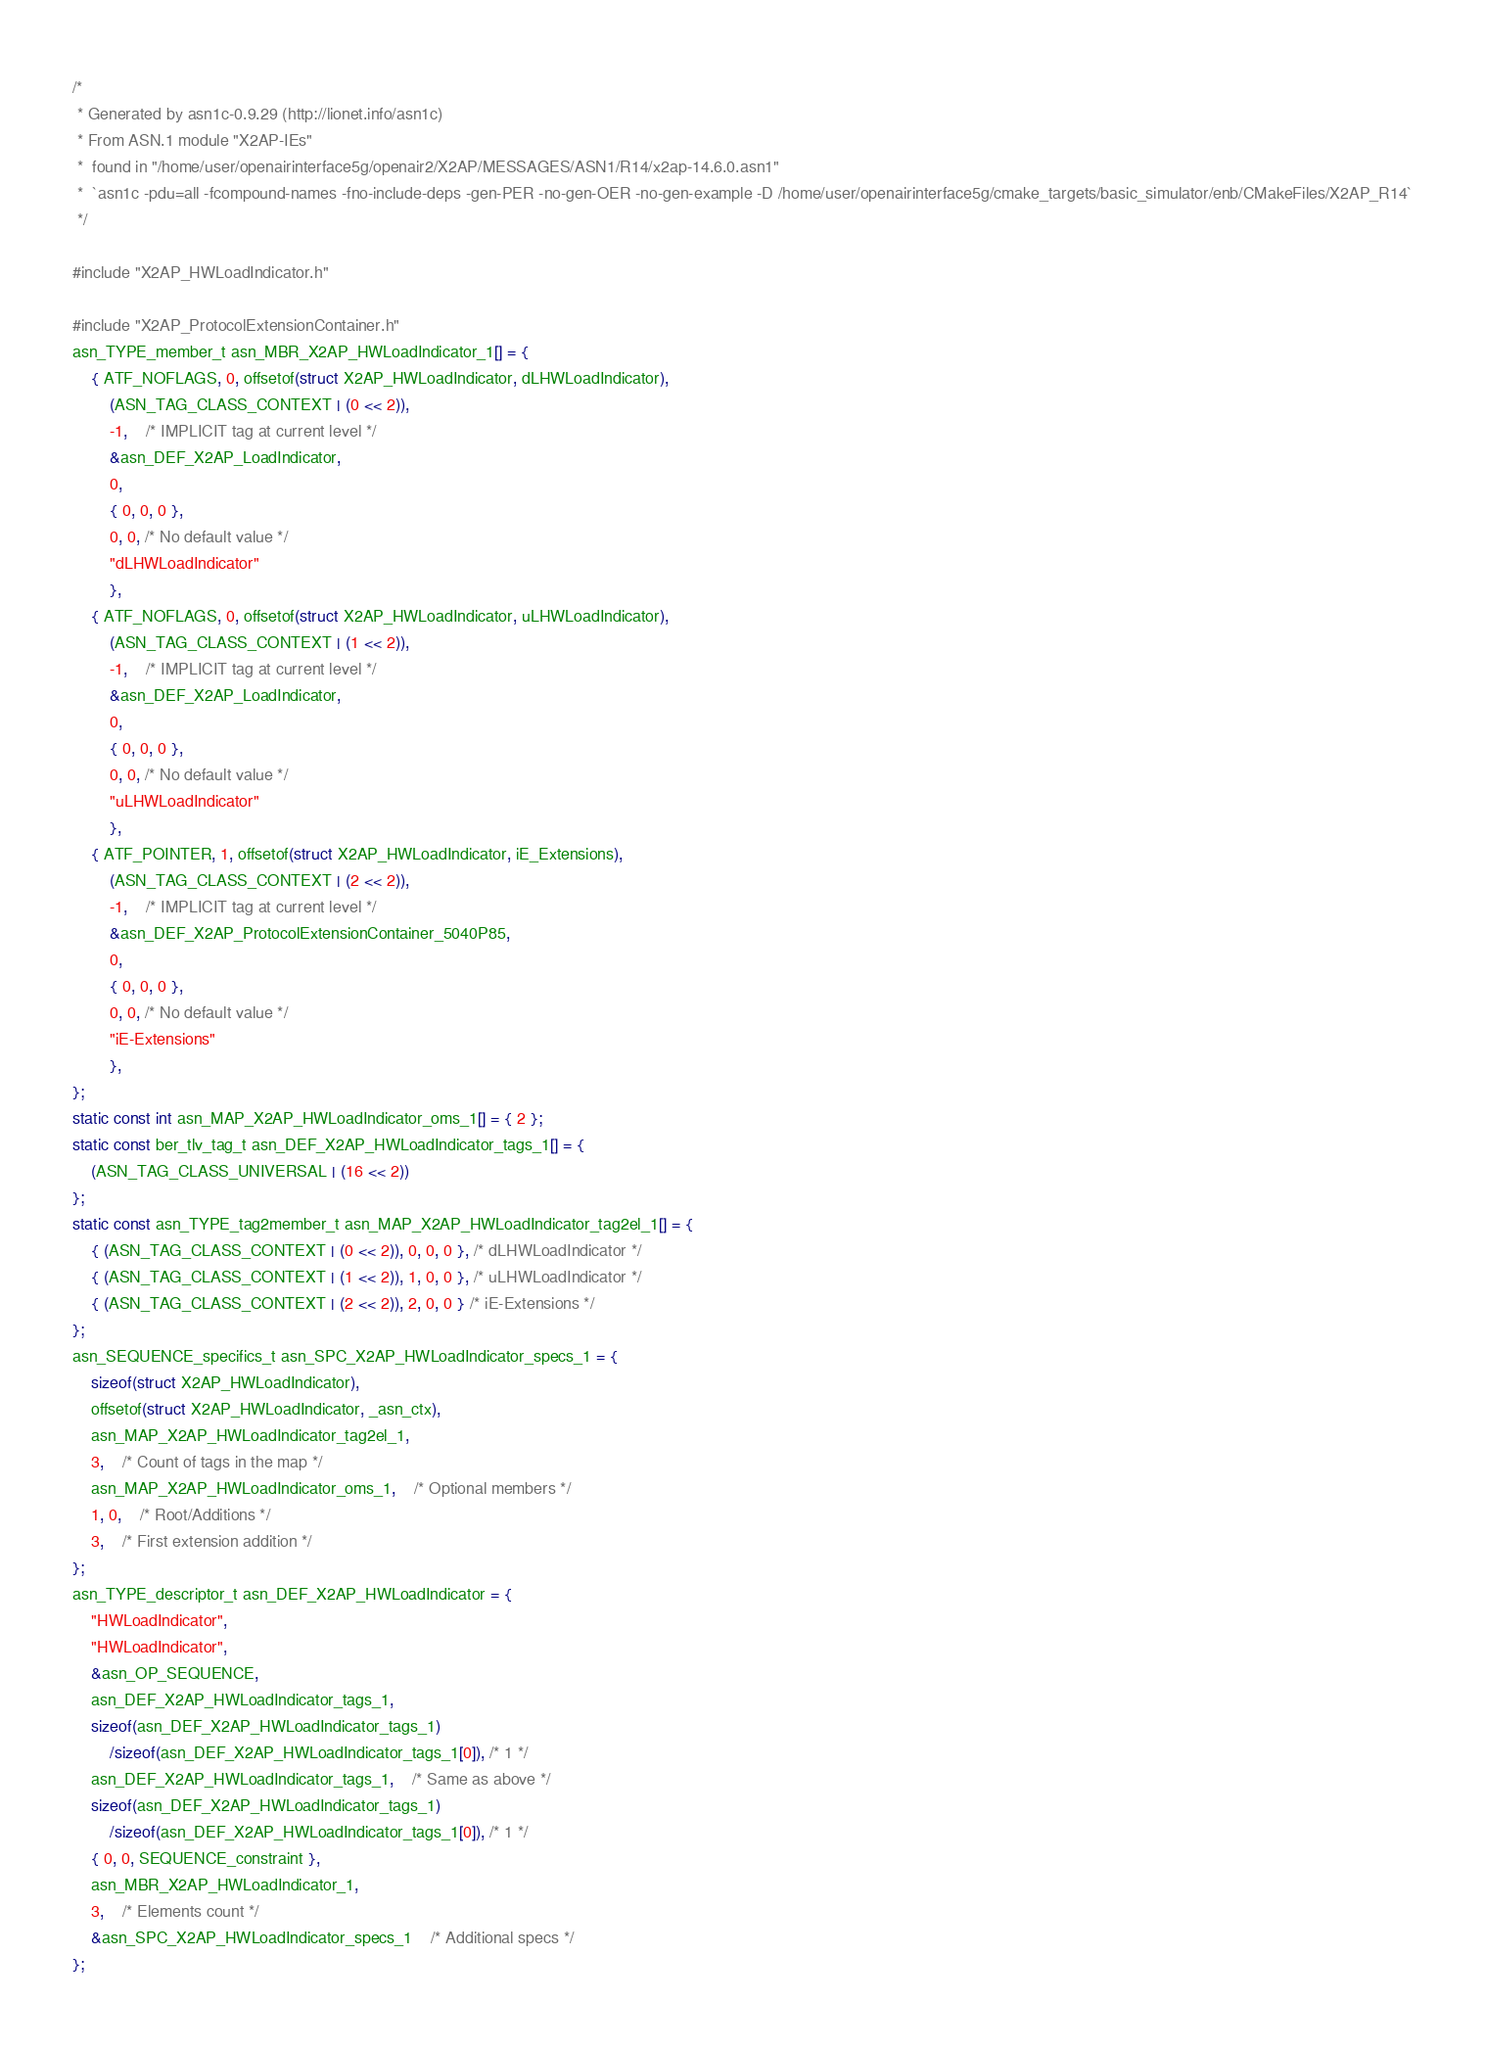<code> <loc_0><loc_0><loc_500><loc_500><_C_>/*
 * Generated by asn1c-0.9.29 (http://lionet.info/asn1c)
 * From ASN.1 module "X2AP-IEs"
 * 	found in "/home/user/openairinterface5g/openair2/X2AP/MESSAGES/ASN1/R14/x2ap-14.6.0.asn1"
 * 	`asn1c -pdu=all -fcompound-names -fno-include-deps -gen-PER -no-gen-OER -no-gen-example -D /home/user/openairinterface5g/cmake_targets/basic_simulator/enb/CMakeFiles/X2AP_R14`
 */

#include "X2AP_HWLoadIndicator.h"

#include "X2AP_ProtocolExtensionContainer.h"
asn_TYPE_member_t asn_MBR_X2AP_HWLoadIndicator_1[] = {
	{ ATF_NOFLAGS, 0, offsetof(struct X2AP_HWLoadIndicator, dLHWLoadIndicator),
		(ASN_TAG_CLASS_CONTEXT | (0 << 2)),
		-1,	/* IMPLICIT tag at current level */
		&asn_DEF_X2AP_LoadIndicator,
		0,
		{ 0, 0, 0 },
		0, 0, /* No default value */
		"dLHWLoadIndicator"
		},
	{ ATF_NOFLAGS, 0, offsetof(struct X2AP_HWLoadIndicator, uLHWLoadIndicator),
		(ASN_TAG_CLASS_CONTEXT | (1 << 2)),
		-1,	/* IMPLICIT tag at current level */
		&asn_DEF_X2AP_LoadIndicator,
		0,
		{ 0, 0, 0 },
		0, 0, /* No default value */
		"uLHWLoadIndicator"
		},
	{ ATF_POINTER, 1, offsetof(struct X2AP_HWLoadIndicator, iE_Extensions),
		(ASN_TAG_CLASS_CONTEXT | (2 << 2)),
		-1,	/* IMPLICIT tag at current level */
		&asn_DEF_X2AP_ProtocolExtensionContainer_5040P85,
		0,
		{ 0, 0, 0 },
		0, 0, /* No default value */
		"iE-Extensions"
		},
};
static const int asn_MAP_X2AP_HWLoadIndicator_oms_1[] = { 2 };
static const ber_tlv_tag_t asn_DEF_X2AP_HWLoadIndicator_tags_1[] = {
	(ASN_TAG_CLASS_UNIVERSAL | (16 << 2))
};
static const asn_TYPE_tag2member_t asn_MAP_X2AP_HWLoadIndicator_tag2el_1[] = {
    { (ASN_TAG_CLASS_CONTEXT | (0 << 2)), 0, 0, 0 }, /* dLHWLoadIndicator */
    { (ASN_TAG_CLASS_CONTEXT | (1 << 2)), 1, 0, 0 }, /* uLHWLoadIndicator */
    { (ASN_TAG_CLASS_CONTEXT | (2 << 2)), 2, 0, 0 } /* iE-Extensions */
};
asn_SEQUENCE_specifics_t asn_SPC_X2AP_HWLoadIndicator_specs_1 = {
	sizeof(struct X2AP_HWLoadIndicator),
	offsetof(struct X2AP_HWLoadIndicator, _asn_ctx),
	asn_MAP_X2AP_HWLoadIndicator_tag2el_1,
	3,	/* Count of tags in the map */
	asn_MAP_X2AP_HWLoadIndicator_oms_1,	/* Optional members */
	1, 0,	/* Root/Additions */
	3,	/* First extension addition */
};
asn_TYPE_descriptor_t asn_DEF_X2AP_HWLoadIndicator = {
	"HWLoadIndicator",
	"HWLoadIndicator",
	&asn_OP_SEQUENCE,
	asn_DEF_X2AP_HWLoadIndicator_tags_1,
	sizeof(asn_DEF_X2AP_HWLoadIndicator_tags_1)
		/sizeof(asn_DEF_X2AP_HWLoadIndicator_tags_1[0]), /* 1 */
	asn_DEF_X2AP_HWLoadIndicator_tags_1,	/* Same as above */
	sizeof(asn_DEF_X2AP_HWLoadIndicator_tags_1)
		/sizeof(asn_DEF_X2AP_HWLoadIndicator_tags_1[0]), /* 1 */
	{ 0, 0, SEQUENCE_constraint },
	asn_MBR_X2AP_HWLoadIndicator_1,
	3,	/* Elements count */
	&asn_SPC_X2AP_HWLoadIndicator_specs_1	/* Additional specs */
};

</code> 